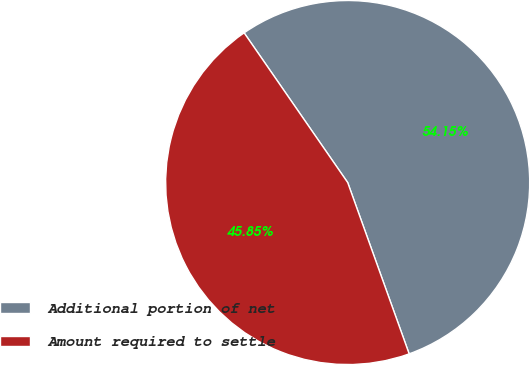Convert chart. <chart><loc_0><loc_0><loc_500><loc_500><pie_chart><fcel>Additional portion of net<fcel>Amount required to settle<nl><fcel>54.15%<fcel>45.85%<nl></chart> 